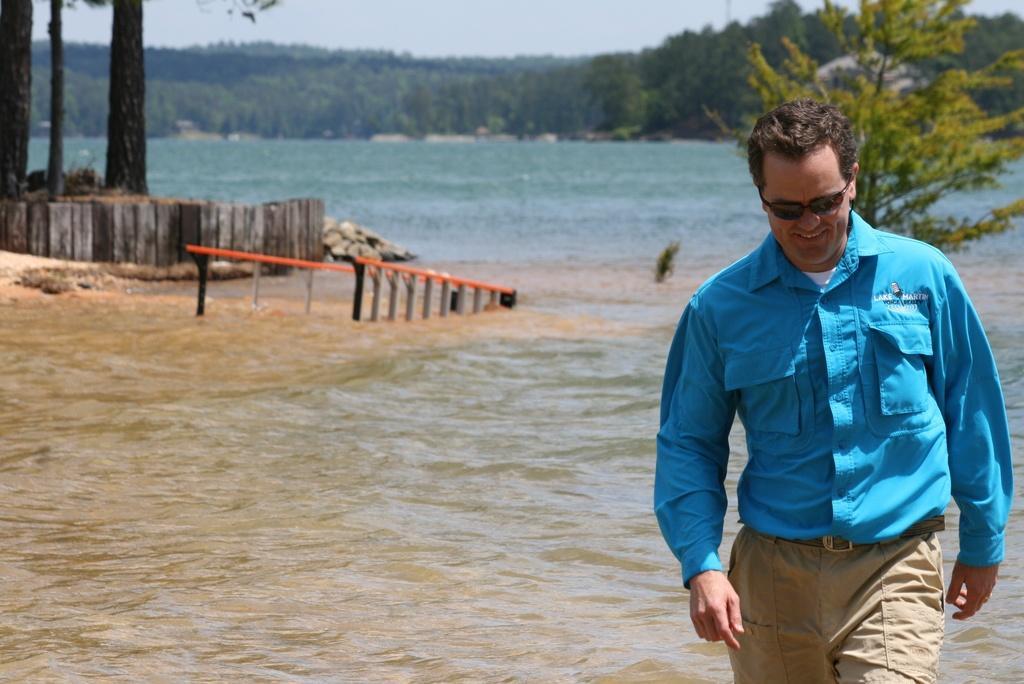Describe this image in one or two sentences. In the background we can see the sky, trees. In this picture we can see the water and it seems like a ladder in the water. On the left side of the picture we can see the stones, wooden railing and the tree trunks. On the right side of the picture we can see a man wearing a blue shirt, goggles and smiling. 